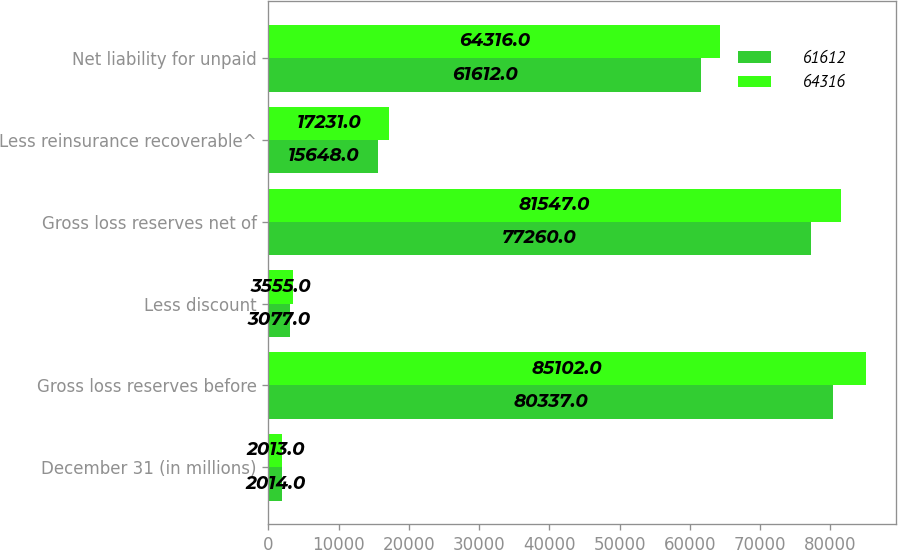Convert chart to OTSL. <chart><loc_0><loc_0><loc_500><loc_500><stacked_bar_chart><ecel><fcel>December 31 (in millions)<fcel>Gross loss reserves before<fcel>Less discount<fcel>Gross loss reserves net of<fcel>Less reinsurance recoverable^<fcel>Net liability for unpaid<nl><fcel>61612<fcel>2014<fcel>80337<fcel>3077<fcel>77260<fcel>15648<fcel>61612<nl><fcel>64316<fcel>2013<fcel>85102<fcel>3555<fcel>81547<fcel>17231<fcel>64316<nl></chart> 